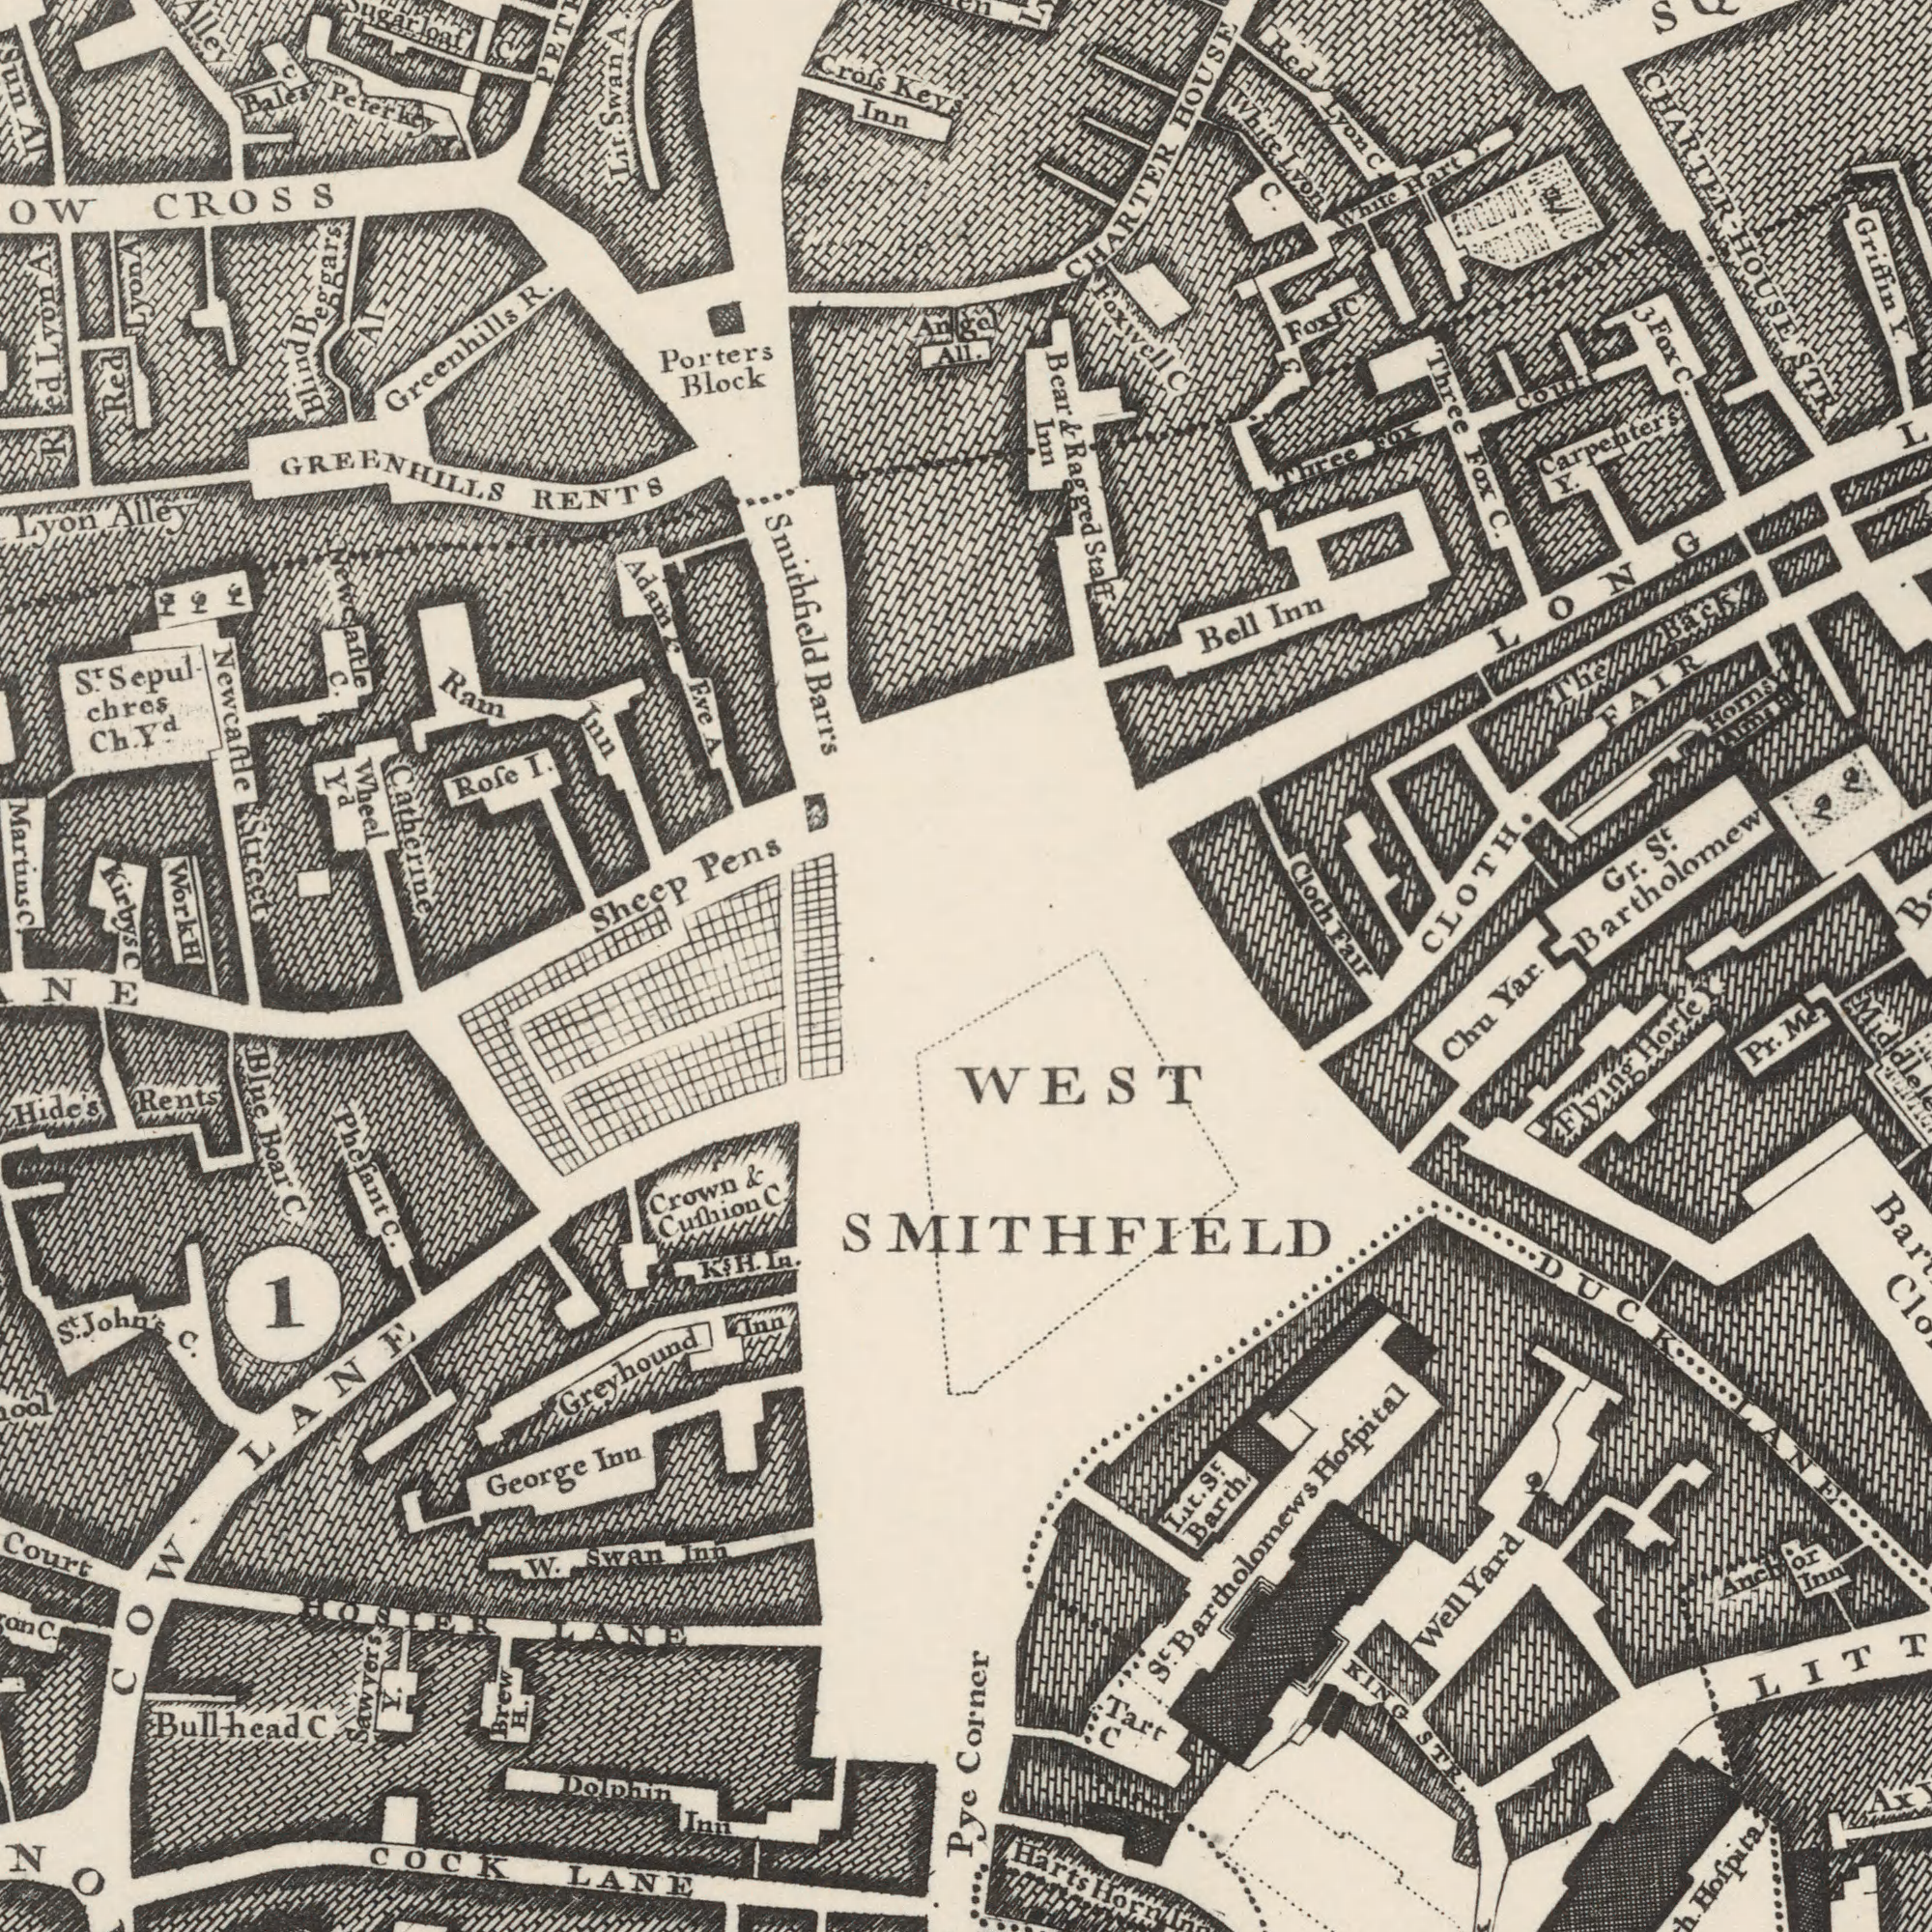What text is visible in the lower-left corner? LANE Hide's Phefant C C. Boar George Dolphin 1 W. Inn LANE Crown C. Inn Sawyers Swan Rents Bullhead COCK Brew Y. St. Inn John's Inn H. C LANE Blue Greyhound TOSIER C. COW & Cufhion C K's. H. In. What text appears in the top-left area of the image? Smithfield Martins Greenhills Pens Kirbys Block Barrs RENTS R. Peterkey Inn Wheel chres CROSS Rofe Porters Sheep Catherine Adam Bales Crofs Eve Ch. Newcaftle Lyon Ram Keys I. Beggars Alley AI Red Red Blind Work Lyon Inn Lit. St. Sepul AI GREENHILLS Sun Newcaftle Street C C Swan Angel All. C. A C. C H Lyon A A Yd. & Yd A. What text is visible in the upper-right corner? Griffin C. Bell Fox C. HOUSE Carpenters CHARTER Lyon CLOTH. Bartholomew St. Y. White Red Hart Court Inn Fox Y. Cloth Three Fair White Lyon Gr. Y. STR The Three Foxwell CHARTER-HOUSE C. C C & Bear & Ragged Staff Fox LONG Back FAIR Horns Y Aims H & Fox C. Inn What text can you see in the bottom-right section? Pye Hofpital Yar. Pr. Harts Barth. Well Chu Yard KING WEST Tart Inn Hofpita STR. Corner Me. Ax Horfe C DUCK Anchor Flying Bartholomews St. LANE SMITHFIELD Y Lit. St. Horn 